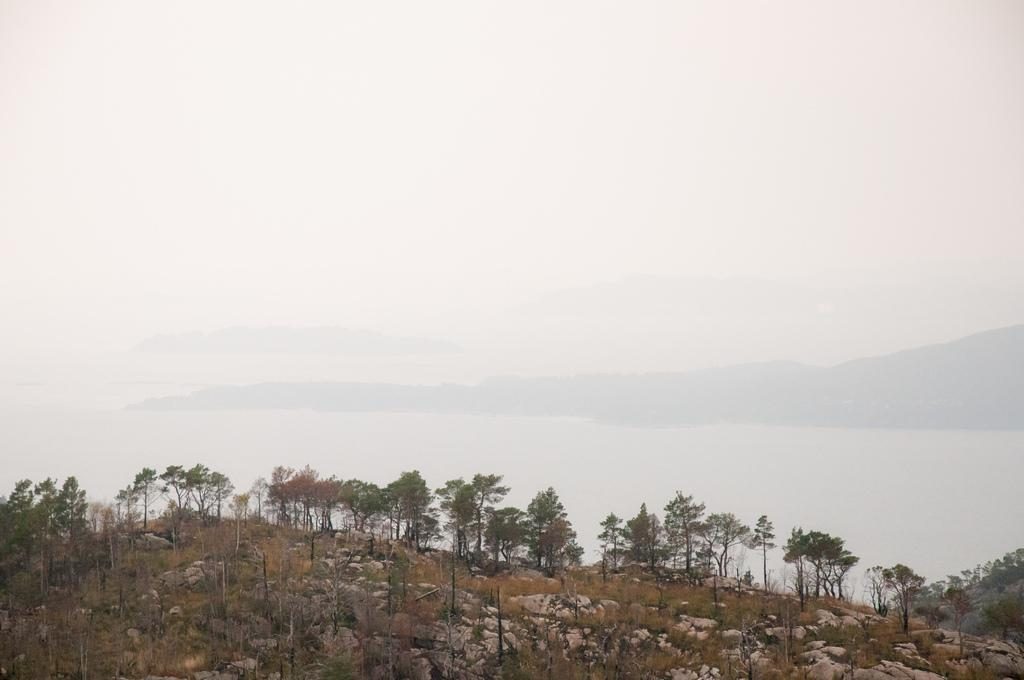What type of vegetation can be seen in the image? There are trees in the image. What is the color of the trees? The trees are green in color. What other objects are present in the image? There are stones in the image. What can be seen in the background of the image? The sky is visible in the background of the image. What is the color of the sky? The sky is white in color. Reasoning: Let's think step by step by step in order to produce the conversation. We start by identifying the main subject in the image, which is the trees. Then, we describe their color and expand the conversation to include other objects present in the image, such as stones. We also mention the background of the image, which is the sky, and describe its color. Each question is designed to elicit a specific detail about the image that is known from the provided facts. Absurd Question/Answer: How does the powder affect the trees in the image? There is no powder present in the image, so it cannot affect the trees. 